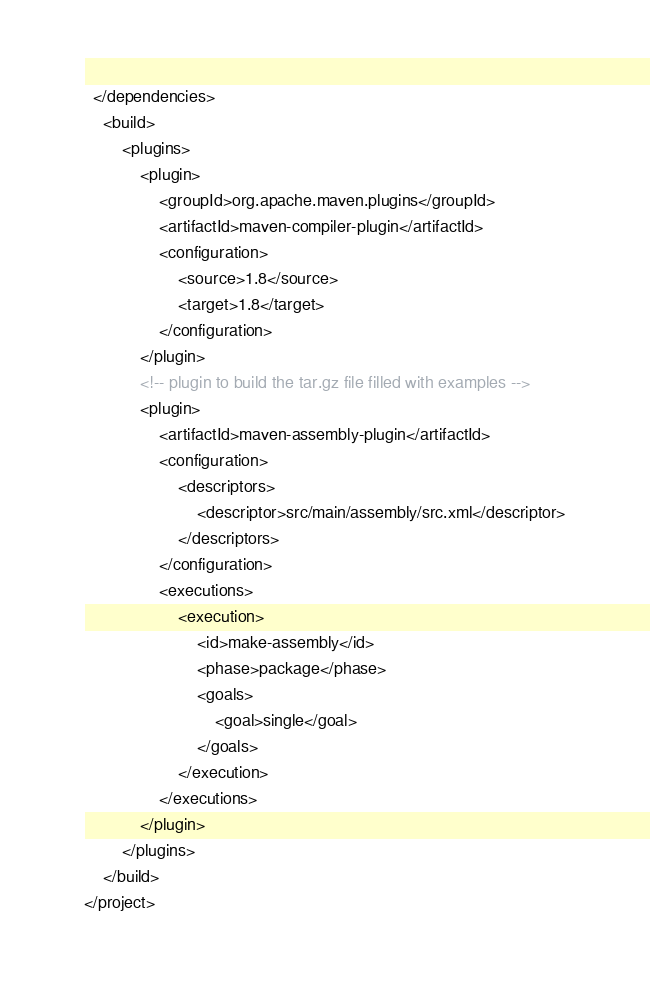<code> <loc_0><loc_0><loc_500><loc_500><_XML_>  </dependencies>
  	<build>
		<plugins>
			<plugin>
				<groupId>org.apache.maven.plugins</groupId>
				<artifactId>maven-compiler-plugin</artifactId>
				<configuration>
					<source>1.8</source>
					<target>1.8</target>
				</configuration>
			</plugin>
			<!-- plugin to build the tar.gz file filled with examples -->
			<plugin>
				<artifactId>maven-assembly-plugin</artifactId>
				<configuration>
					<descriptors>
						<descriptor>src/main/assembly/src.xml</descriptor>
					</descriptors>
				</configuration>
				<executions>
					<execution>
						<id>make-assembly</id>
						<phase>package</phase>
						<goals>
							<goal>single</goal>
						</goals>
					</execution>
				</executions>
			</plugin>
		</plugins>
	</build>
</project>
</code> 